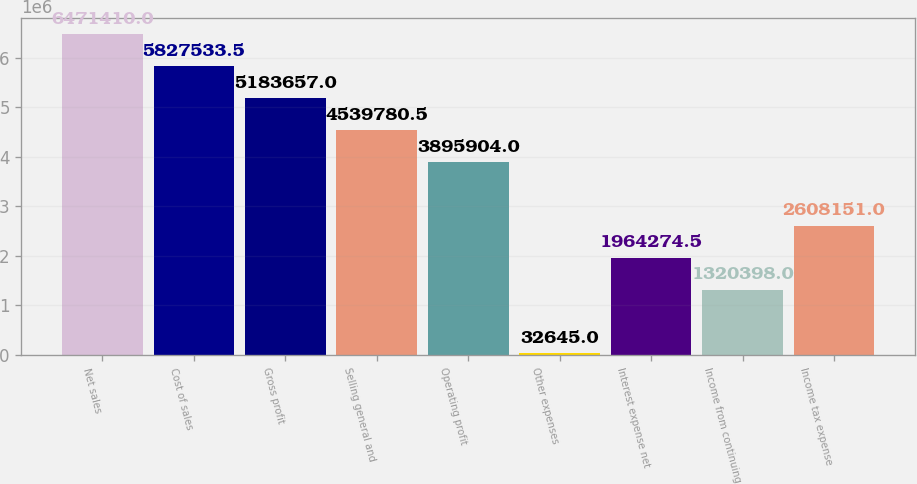Convert chart. <chart><loc_0><loc_0><loc_500><loc_500><bar_chart><fcel>Net sales<fcel>Cost of sales<fcel>Gross profit<fcel>Selling general and<fcel>Operating profit<fcel>Other expenses<fcel>Interest expense net<fcel>Income from continuing<fcel>Income tax expense<nl><fcel>6.47141e+06<fcel>5.82753e+06<fcel>5.18366e+06<fcel>4.53978e+06<fcel>3.8959e+06<fcel>32645<fcel>1.96427e+06<fcel>1.3204e+06<fcel>2.60815e+06<nl></chart> 